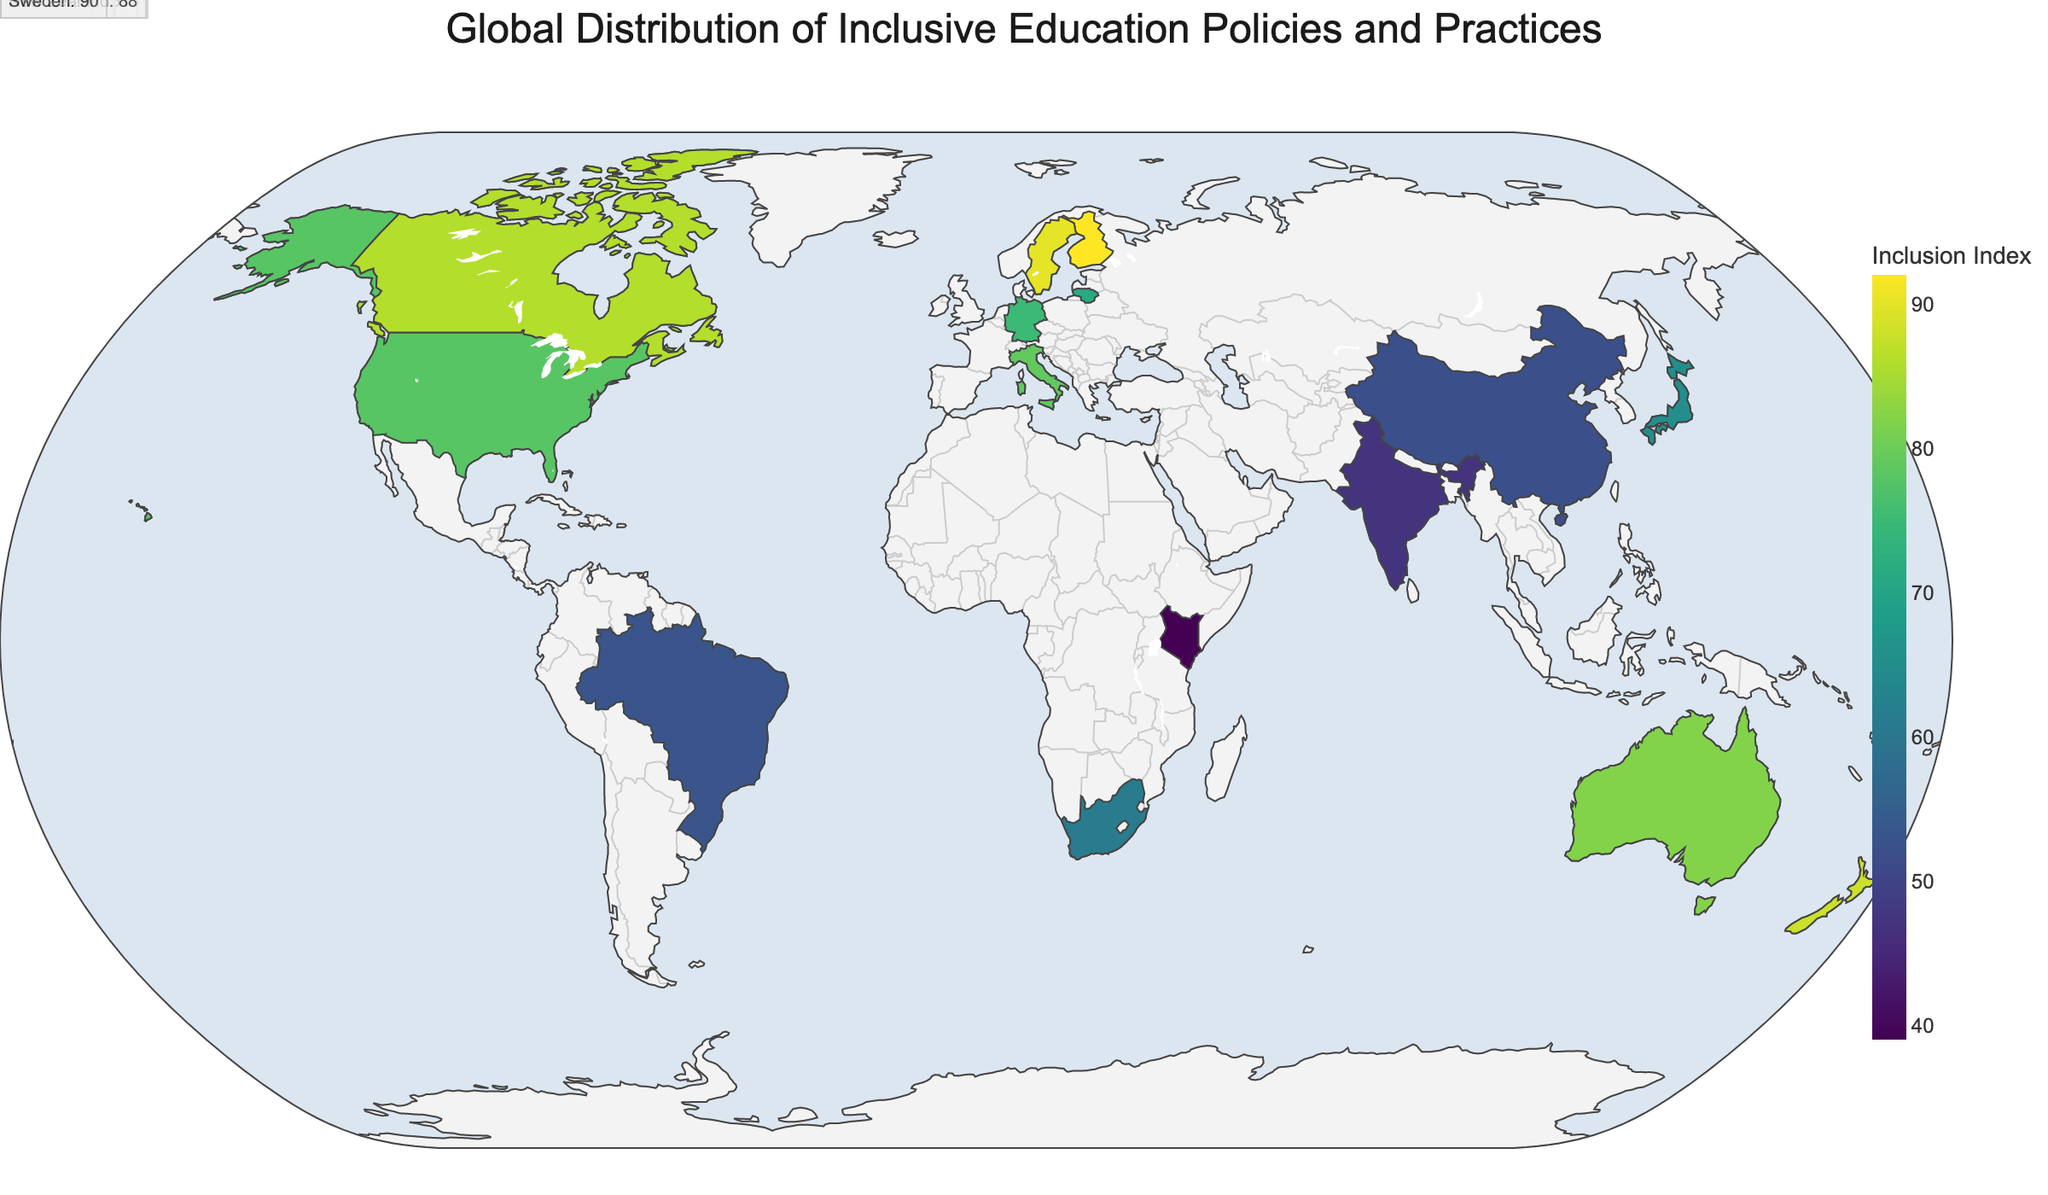What is the title of the figure? The title is usually displayed at the top of the plot. In this figure, it indicates the main subject being visualized.
Answer: Global Distribution of Inclusive Education Policies and Practices Which country has the highest Inclusion Index? The figure will have varying colors representing the Inclusion Index. The country with the darkest color on the Viridis scale has the highest Inclusion Index.
Answer: Finland What law represents inclusive education in Lithuania? Hovering over Lithuania in the plot will display details about its inclusive education policy.
Answer: Law on Education How many countries have an Inclusion Index greater than 80? By looking at the color scale and the individual values displayed, count the countries with an Inclusion Index above 80.
Answer: Four (Finland, Australia, New Zealand, Sweden) Compare the Inclusion Index of Canada and Germany. Which one is higher? Locate Canada and Germany on the map. Compare the numerical Inclusion Index values shown for each country.
Answer: Canada What is the average Inclusion Index of the countries listed in the figure? Sum all Inclusion Index values and divide by the total number of countries: (78 + 92 + 65 + 53 + 61 + 82 + 47 + 75 + 86 + 71 + 79 + 39 + 52 + 88 + 90) / 15 = 74.87
Answer: 74.87 Which continent has the most countries listed in the figure? Identify the countries and note their respective continents. Count and compare the number of countries from each continent.
Answer: Europe What is the Inclusion Index of the country with the "White Paper 6 on Special Needs Education" policy? Find the country associated with this policy by hovering over each country until identifying the correct one, which is South Africa.
Answer: 61 Which country has a similar Inclusion Index to Germany? Identify Germany's Inclusion Index (75) and find other countries with similar values by comparing the displayed numbers.
Answer: United States (78) What is the range of the Inclusion Index values displayed in the figure? Subtract the smallest Inclusion Index from the largest Inclusion Index in the dataset: 92 (Finland) - 39 (Kenya) = 53.
Answer: 53 